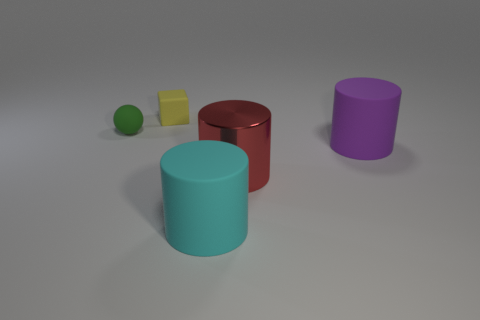Add 4 big red objects. How many objects exist? 9 Subtract all balls. How many objects are left? 4 Add 2 purple cylinders. How many purple cylinders are left? 3 Add 3 large purple cylinders. How many large purple cylinders exist? 4 Subtract 0 cyan balls. How many objects are left? 5 Subtract all small green objects. Subtract all blocks. How many objects are left? 3 